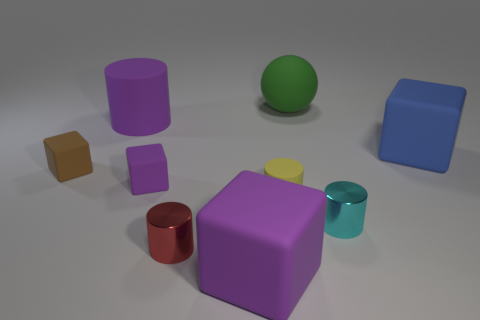Subtract all blue balls. Subtract all green cylinders. How many balls are left? 1 Add 1 tiny brown shiny cubes. How many objects exist? 10 Subtract all cubes. How many objects are left? 5 Add 8 large purple matte cubes. How many large purple matte cubes are left? 9 Add 9 purple cylinders. How many purple cylinders exist? 10 Subtract 1 cyan cylinders. How many objects are left? 8 Subtract all blue rubber objects. Subtract all blue things. How many objects are left? 7 